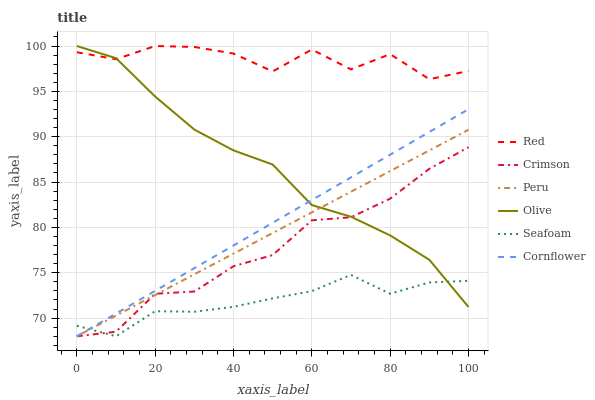Does Seafoam have the minimum area under the curve?
Answer yes or no. Yes. Does Red have the maximum area under the curve?
Answer yes or no. Yes. Does Olive have the minimum area under the curve?
Answer yes or no. No. Does Olive have the maximum area under the curve?
Answer yes or no. No. Is Cornflower the smoothest?
Answer yes or no. Yes. Is Red the roughest?
Answer yes or no. Yes. Is Seafoam the smoothest?
Answer yes or no. No. Is Seafoam the roughest?
Answer yes or no. No. Does Cornflower have the lowest value?
Answer yes or no. Yes. Does Olive have the lowest value?
Answer yes or no. No. Does Red have the highest value?
Answer yes or no. Yes. Does Seafoam have the highest value?
Answer yes or no. No. Is Crimson less than Red?
Answer yes or no. Yes. Is Red greater than Crimson?
Answer yes or no. Yes. Does Olive intersect Peru?
Answer yes or no. Yes. Is Olive less than Peru?
Answer yes or no. No. Is Olive greater than Peru?
Answer yes or no. No. Does Crimson intersect Red?
Answer yes or no. No. 